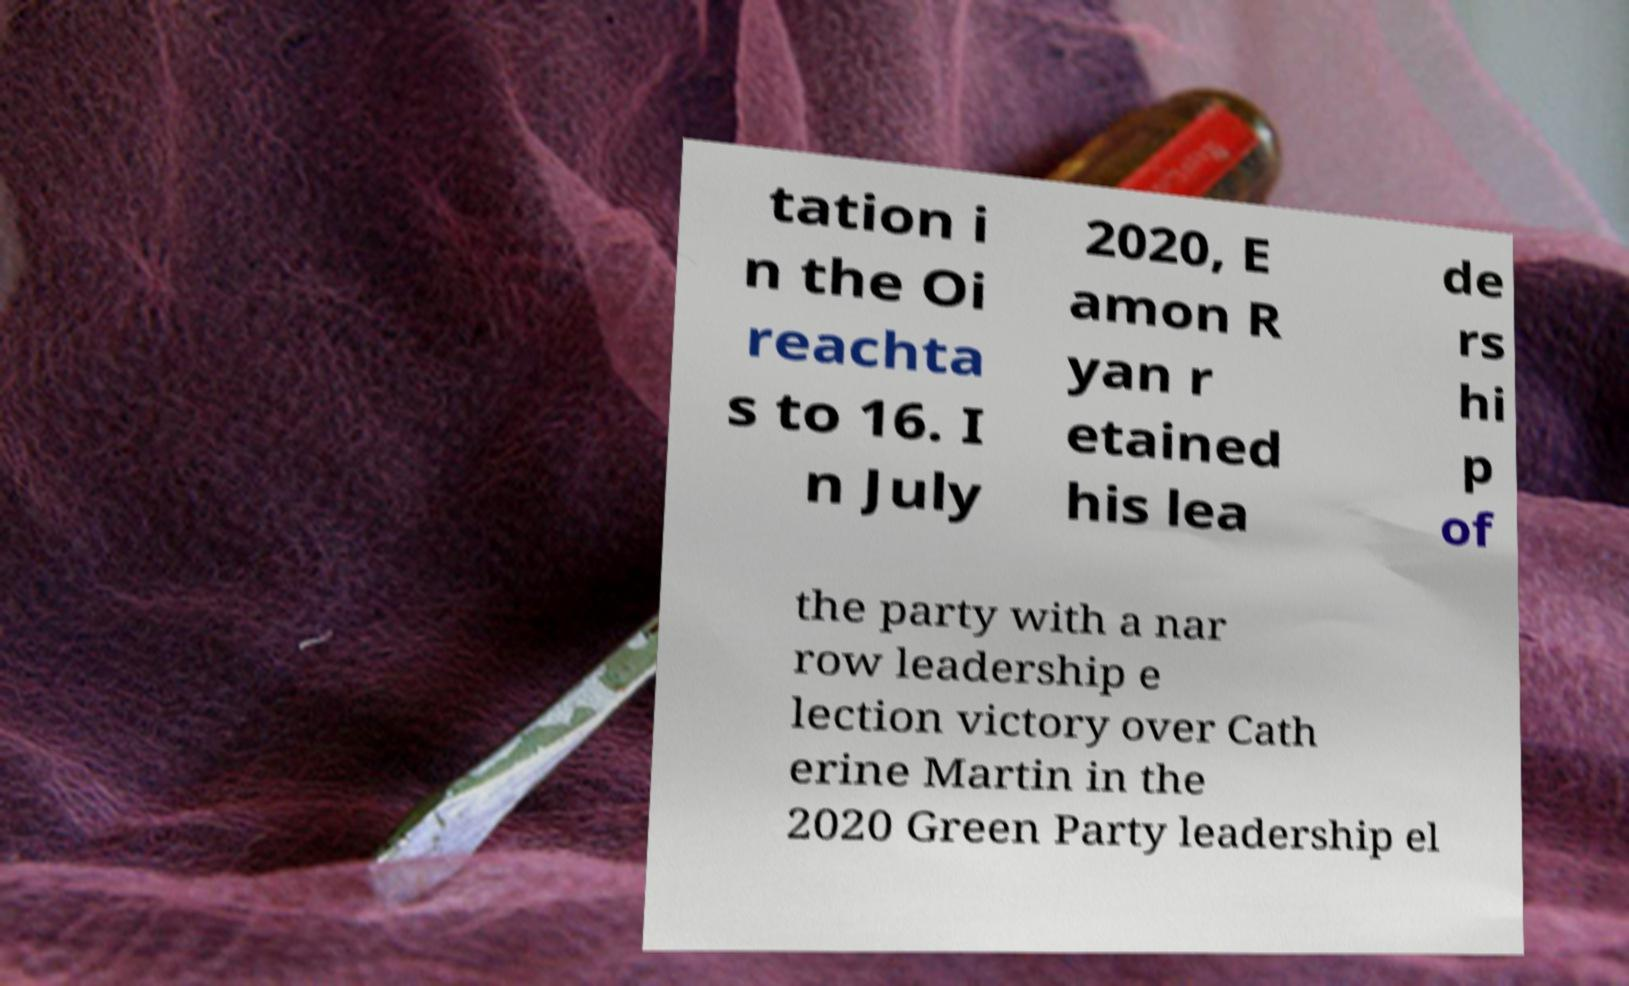There's text embedded in this image that I need extracted. Can you transcribe it verbatim? tation i n the Oi reachta s to 16. I n July 2020, E amon R yan r etained his lea de rs hi p of the party with a nar row leadership e lection victory over Cath erine Martin in the 2020 Green Party leadership el 